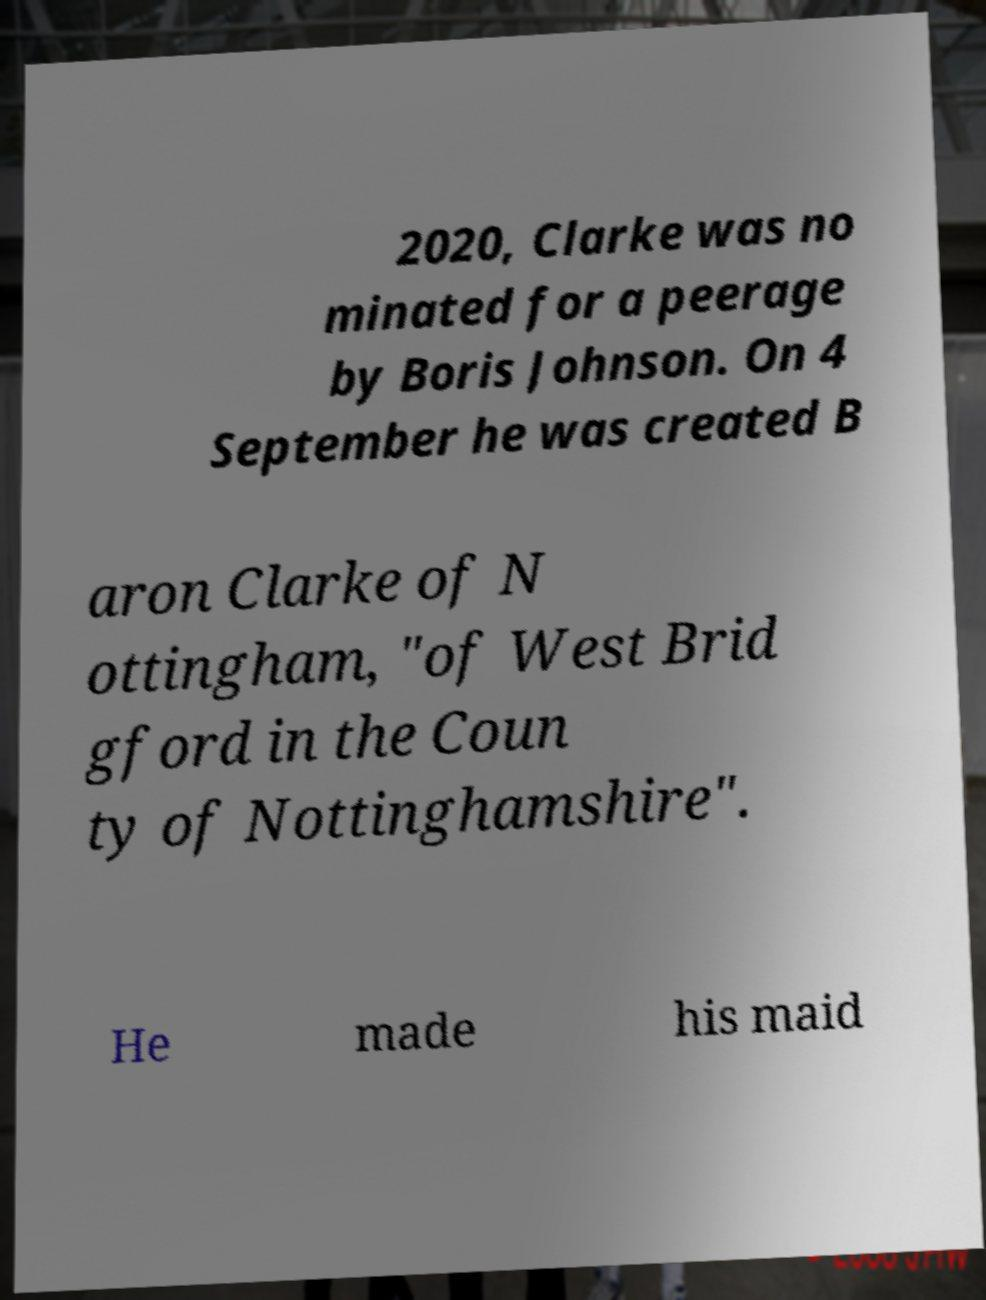Please identify and transcribe the text found in this image. 2020, Clarke was no minated for a peerage by Boris Johnson. On 4 September he was created B aron Clarke of N ottingham, "of West Brid gford in the Coun ty of Nottinghamshire". He made his maid 